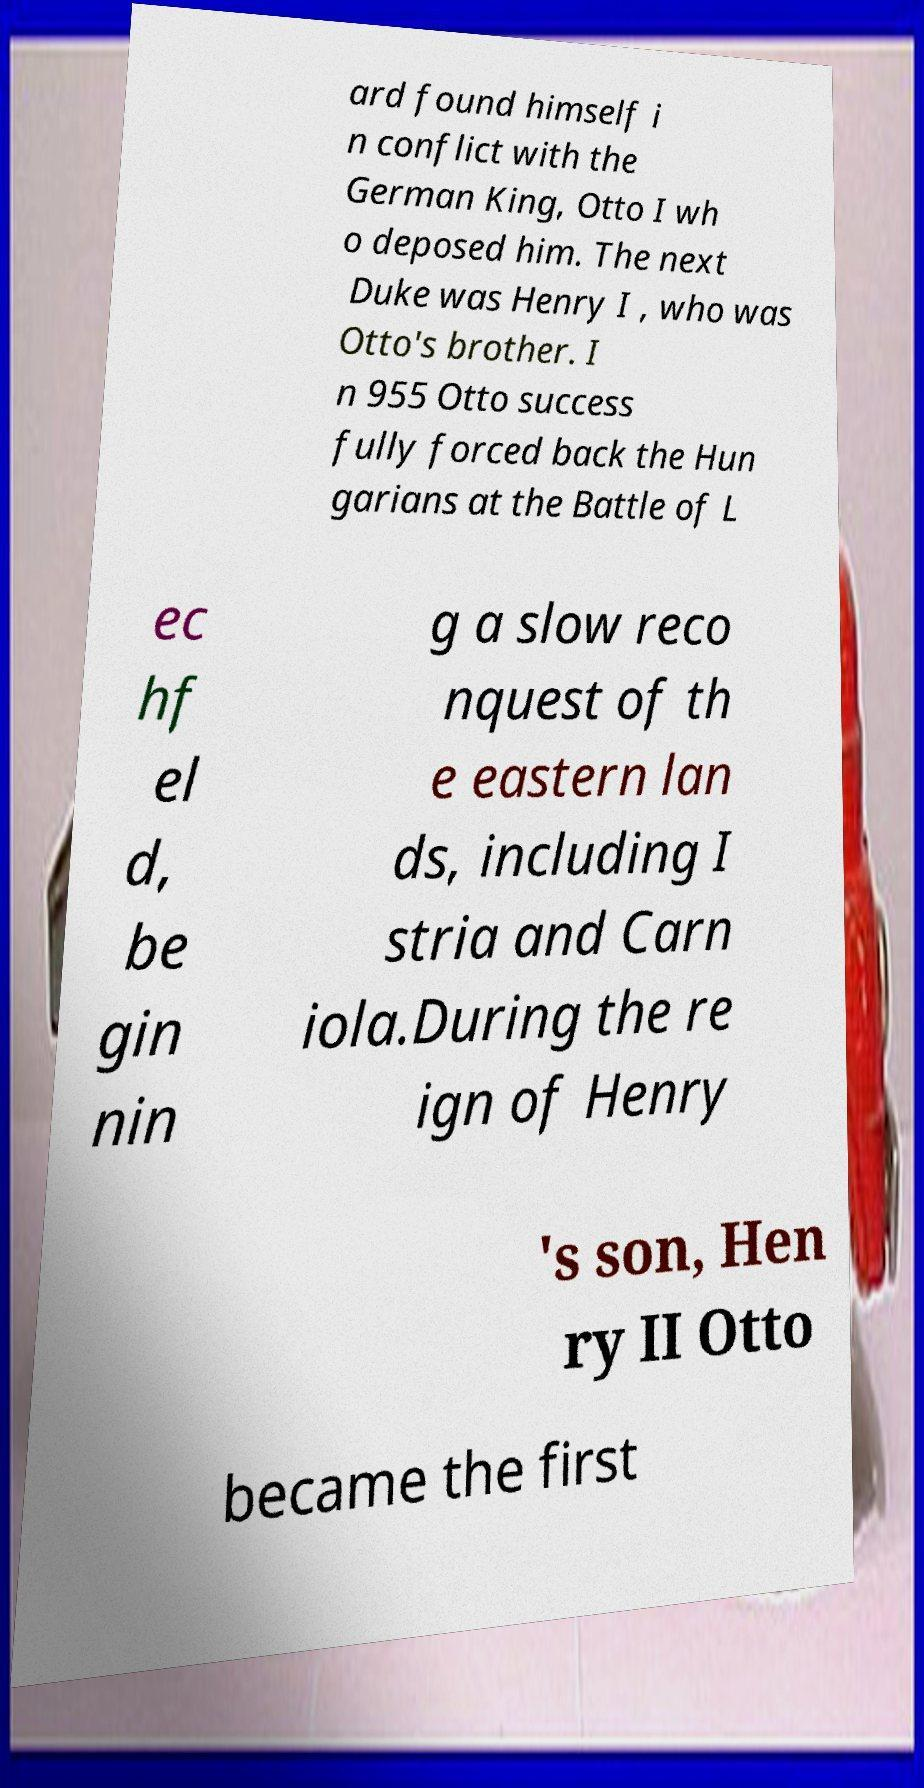Please read and relay the text visible in this image. What does it say? ard found himself i n conflict with the German King, Otto I wh o deposed him. The next Duke was Henry I , who was Otto's brother. I n 955 Otto success fully forced back the Hun garians at the Battle of L ec hf el d, be gin nin g a slow reco nquest of th e eastern lan ds, including I stria and Carn iola.During the re ign of Henry 's son, Hen ry II Otto became the first 